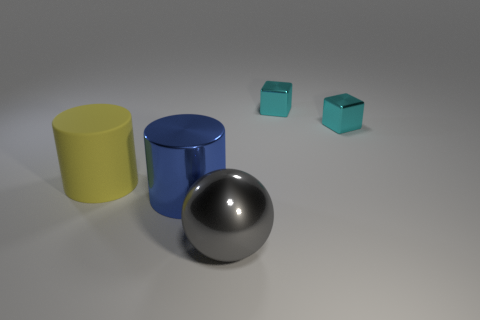There is a large cylinder that is behind the blue metallic cylinder; does it have the same color as the metallic ball?
Your answer should be compact. No. What number of things are big red cubes or large cylinders in front of the matte cylinder?
Your response must be concise. 1. What is the large object that is both in front of the yellow rubber thing and to the left of the big ball made of?
Your answer should be compact. Metal. What material is the cylinder to the right of the large matte cylinder?
Offer a terse response. Metal. There is a cylinder that is made of the same material as the gray sphere; what color is it?
Provide a short and direct response. Blue. There is a large gray metal object; does it have the same shape as the big shiny thing that is behind the gray thing?
Your answer should be compact. No. Are there any large gray shiny things left of the gray object?
Your response must be concise. No. There is a gray shiny ball; is it the same size as the cylinder in front of the large matte object?
Your answer should be very brief. Yes. Is there a metallic sphere of the same color as the matte cylinder?
Make the answer very short. No. Is there a blue metallic thing that has the same shape as the large matte object?
Offer a terse response. Yes. 